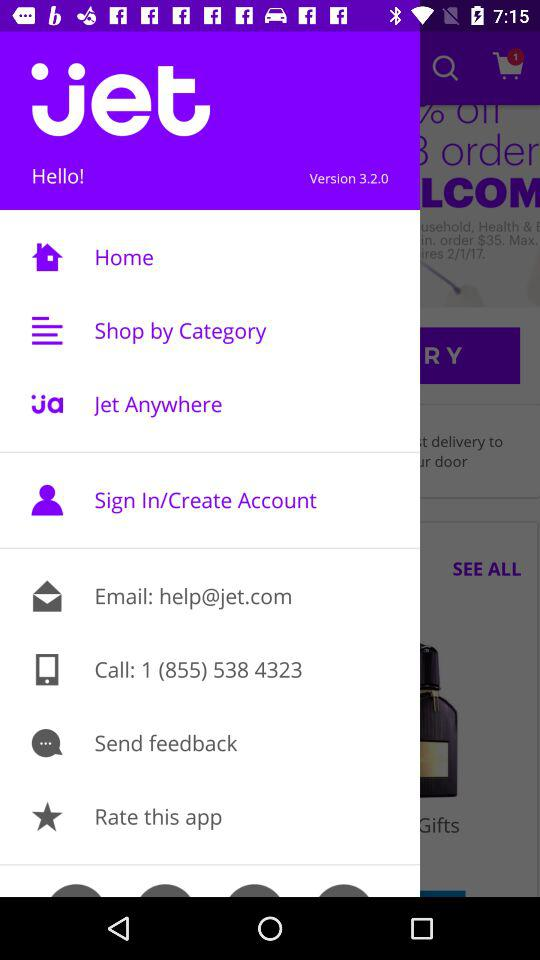What is the email address? The email address is help@jet.com. 